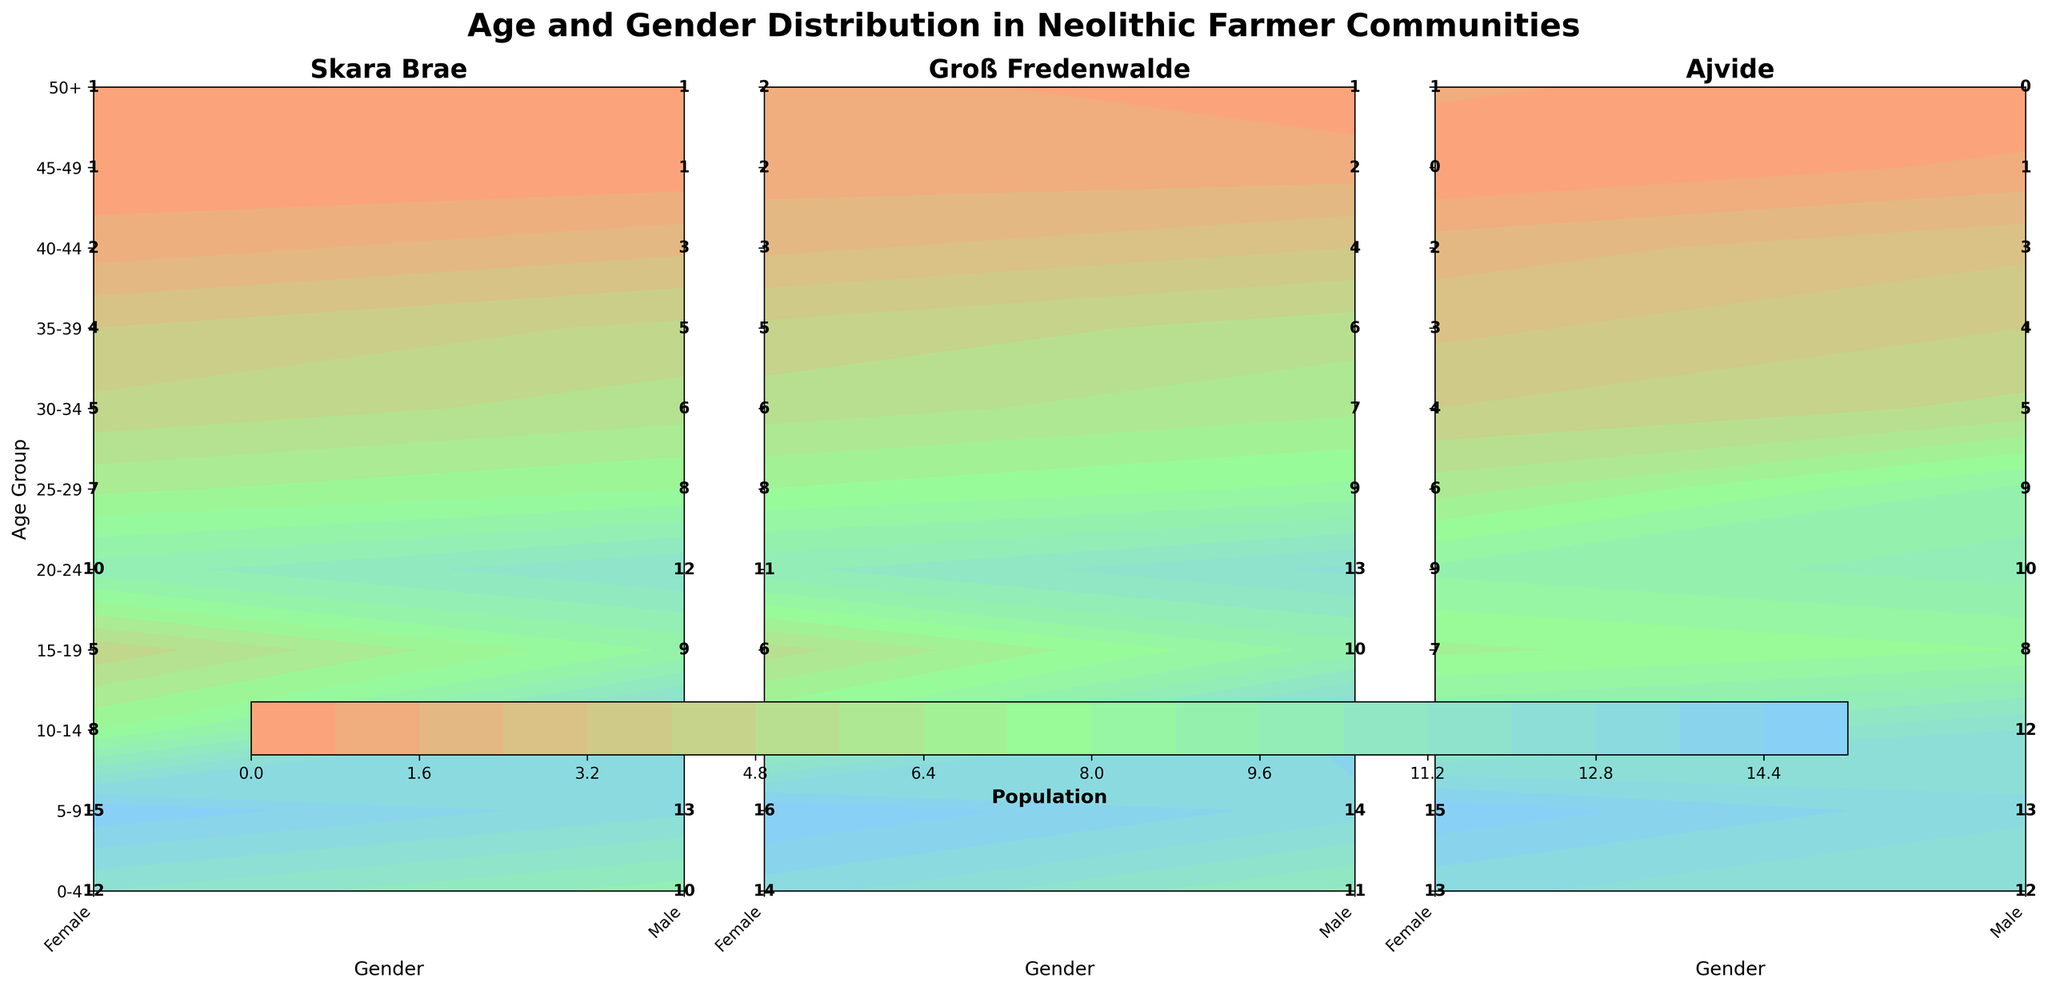What is the title of the figure? The title is displayed at the top of the plot in bold and large font, and it reads "Age and Gender Distribution in Neolithic Farmer Communities".
Answer: Age and Gender Distribution in Neolithic Farmer Communities Which age group has the highest population count in the Skara Brae community? By looking at the contour plot for Skara Brae, observe the labels within the colored regions. The age group 5-9 has the highest population counts, with values of 15 for females and 13 for males, making it the highest.
Answer: 5-9 How many men aged 30-34 live in the Ajvide community? Locate the Ajvide community subplot and find the intersection of the '30-34' age group row and 'Male' gender column. The label at this intersection indicates 5.
Answer: 5 What is the total population of the 20-24 age group in the Groß Fredenwalde community? In the Groß Fredenwalde subplot, add the values for both genders in the '20-24' age group: 11 (female) + 13 (male) = 24.
Answer: 24 